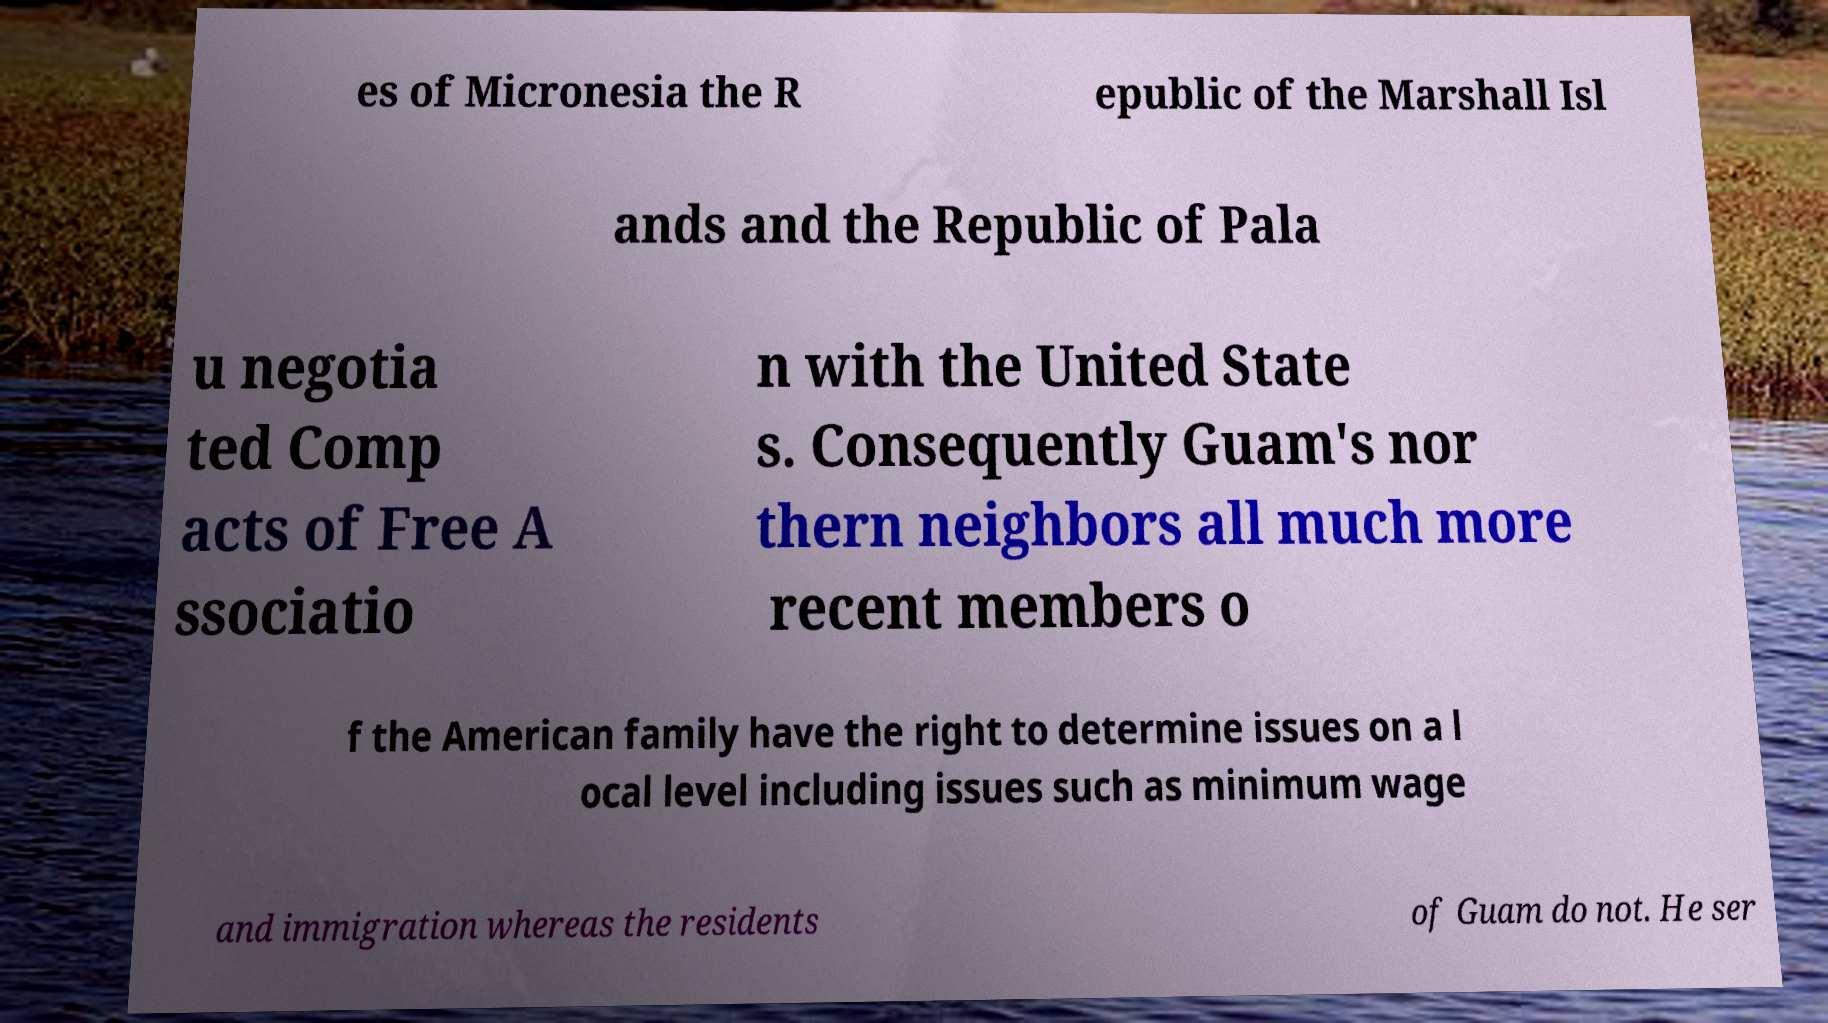What messages or text are displayed in this image? I need them in a readable, typed format. es of Micronesia the R epublic of the Marshall Isl ands and the Republic of Pala u negotia ted Comp acts of Free A ssociatio n with the United State s. Consequently Guam's nor thern neighbors all much more recent members o f the American family have the right to determine issues on a l ocal level including issues such as minimum wage and immigration whereas the residents of Guam do not. He ser 